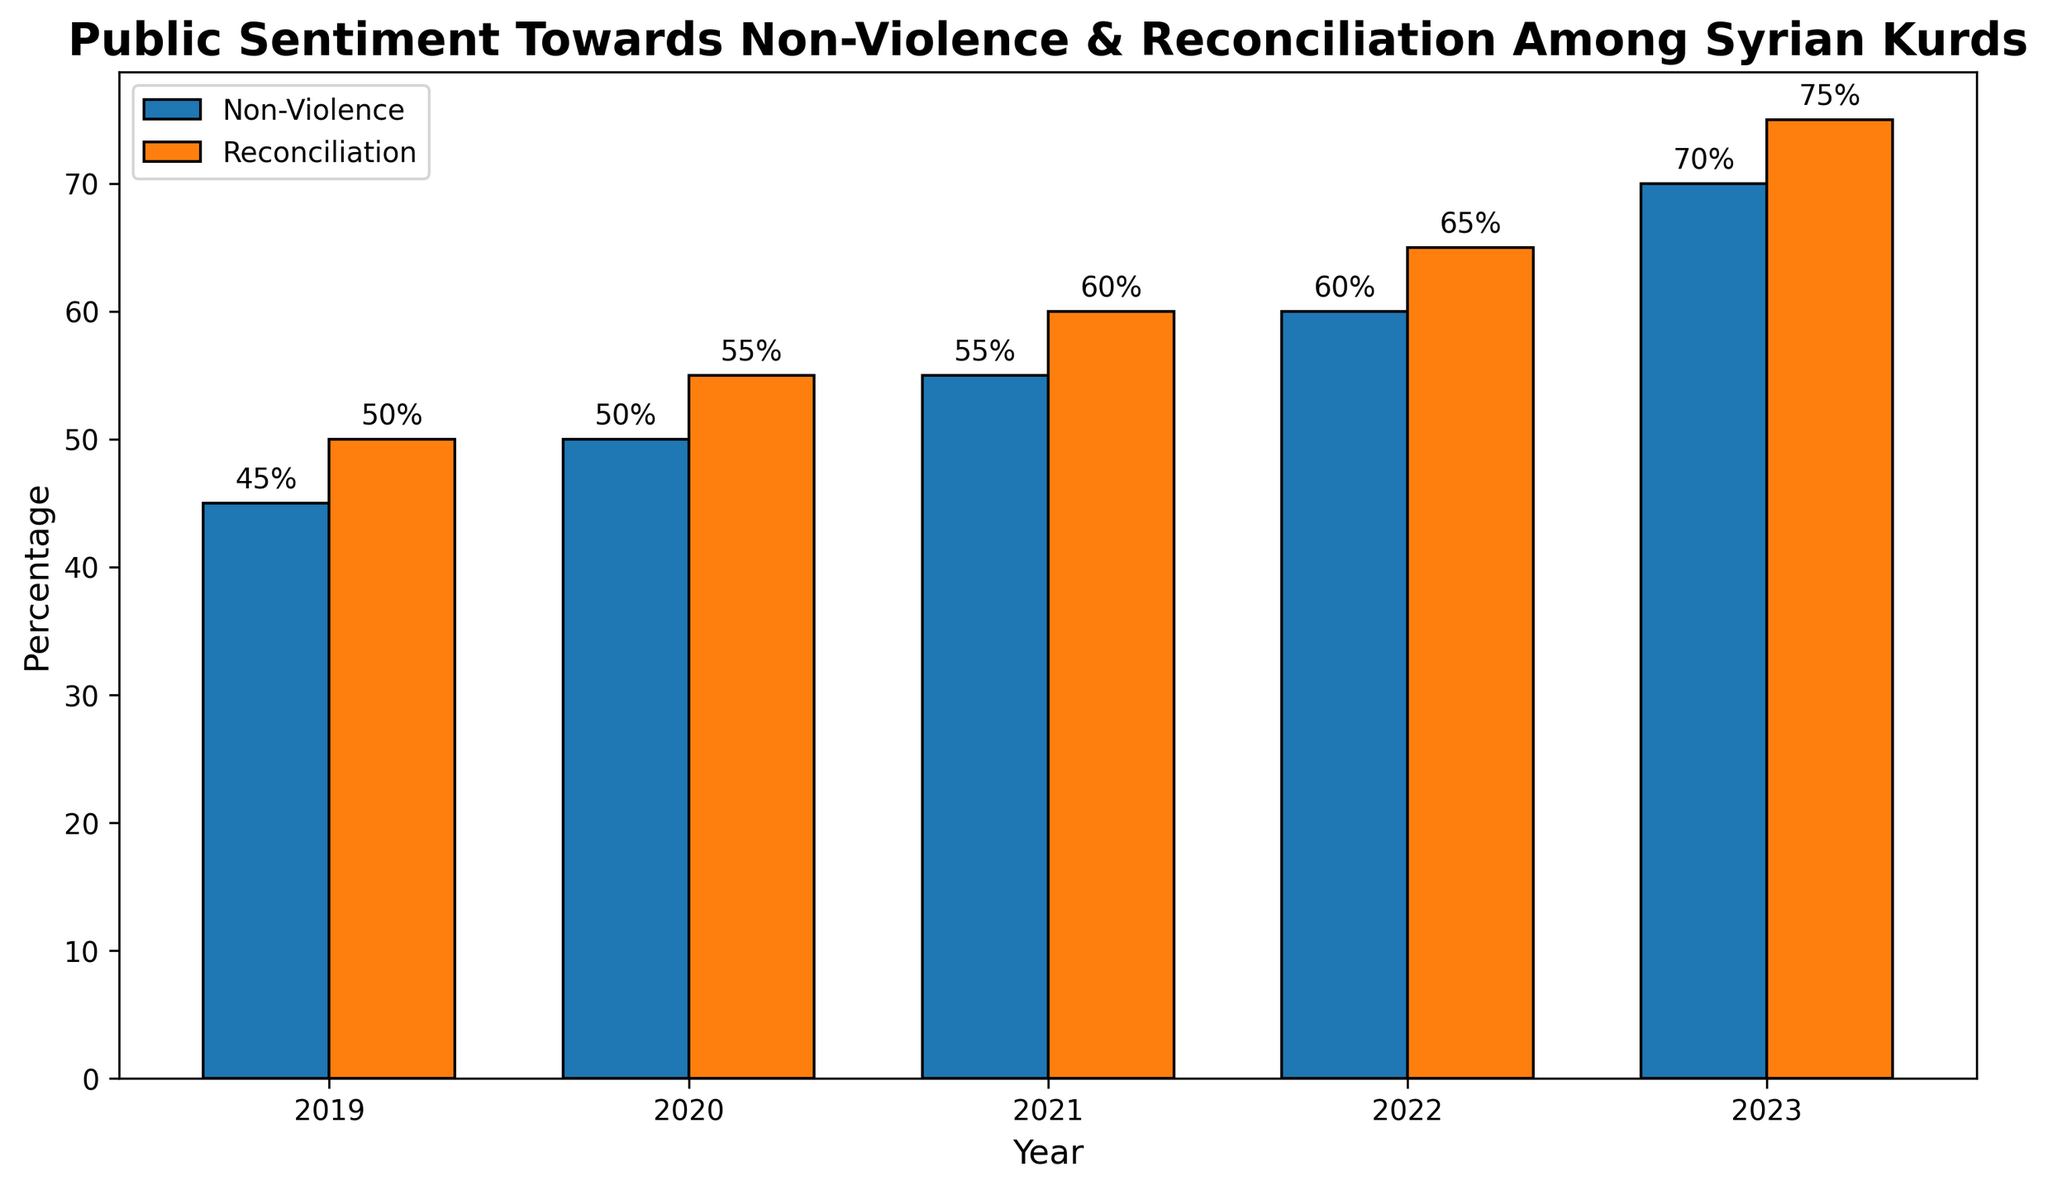What is the percentage of the population supporting non-violence in 2020? Look at the height of the bar labeled "Non-Violence" for the year 2020. The value is shown at the top of the bar.
Answer: 50% What is the difference in the percentage of the population supporting reconciliation between 2020 and 2023? Determine the percentage for 2020 and 2023 from the "Reconciliation" bars, then subtract the former from the latter: 75% (2023) - 55% (2020).
Answer: 20% Which year has the highest percentage of the population supporting non-violence? Identify the highest bar in the "Non-Violence" category and read the corresponding year from the x-axis labels.
Answer: 2023 Compare the trends in the support for non-violence and reconciliation from 2019 to 2023. Are they increasing at the same rate? Observe the height of the bars for both categories over the years. Both show an increasing trend, but the rate of increase for reconciliation seems consistent and slightly higher.
Answer: Both are increasing, but reconciliation is slightly higher What is the average percentage of the population supporting non-violence from 2019 to 2023? Add up the percentages for non-violence for all years (45% + 50% + 55% + 60% + 70%) and divide by the number of years (5).
Answer: 56% How does the percentage of the population supporting non-violence in 2022 compare to the percentage supporting reconciliation in 2019? Look at the bars for non-violence in 2022 and reconciliation in 2019 and compare their heights directly as visual comparison.
Answer: 60% (non-violence in 2022) is greater than 50% (reconciliation in 2019) What is the total combined percentage of the population supporting non-violence and reconciliation in 2021? Add the percentages for non-violence and reconciliation for 2021: 55% + 60%.
Answer: 115% Between which two consecutive years did the percentage of the population supporting reconciliation increase the most? Compare the differences year-to-year for the reconciliation bars:
2019-2020: 55% - 50% = 5%
2020-2021: 60% - 55% = 5%
2021-2022: 65% - 60% = 5%
2022-2023: 75% - 65% = 10%.  
Identify the highest increase.
Answer: 2022-2023 Is there any year where the percentage of the population supporting non-violence is equal to the percentage supporting reconciliation from a different year? Scan the heights of the bars to check the conditions: e.g., *Non-violence* 2019 (45%) is nothing equals any *Reconciliation* year. Continue this way.
Answer: No 